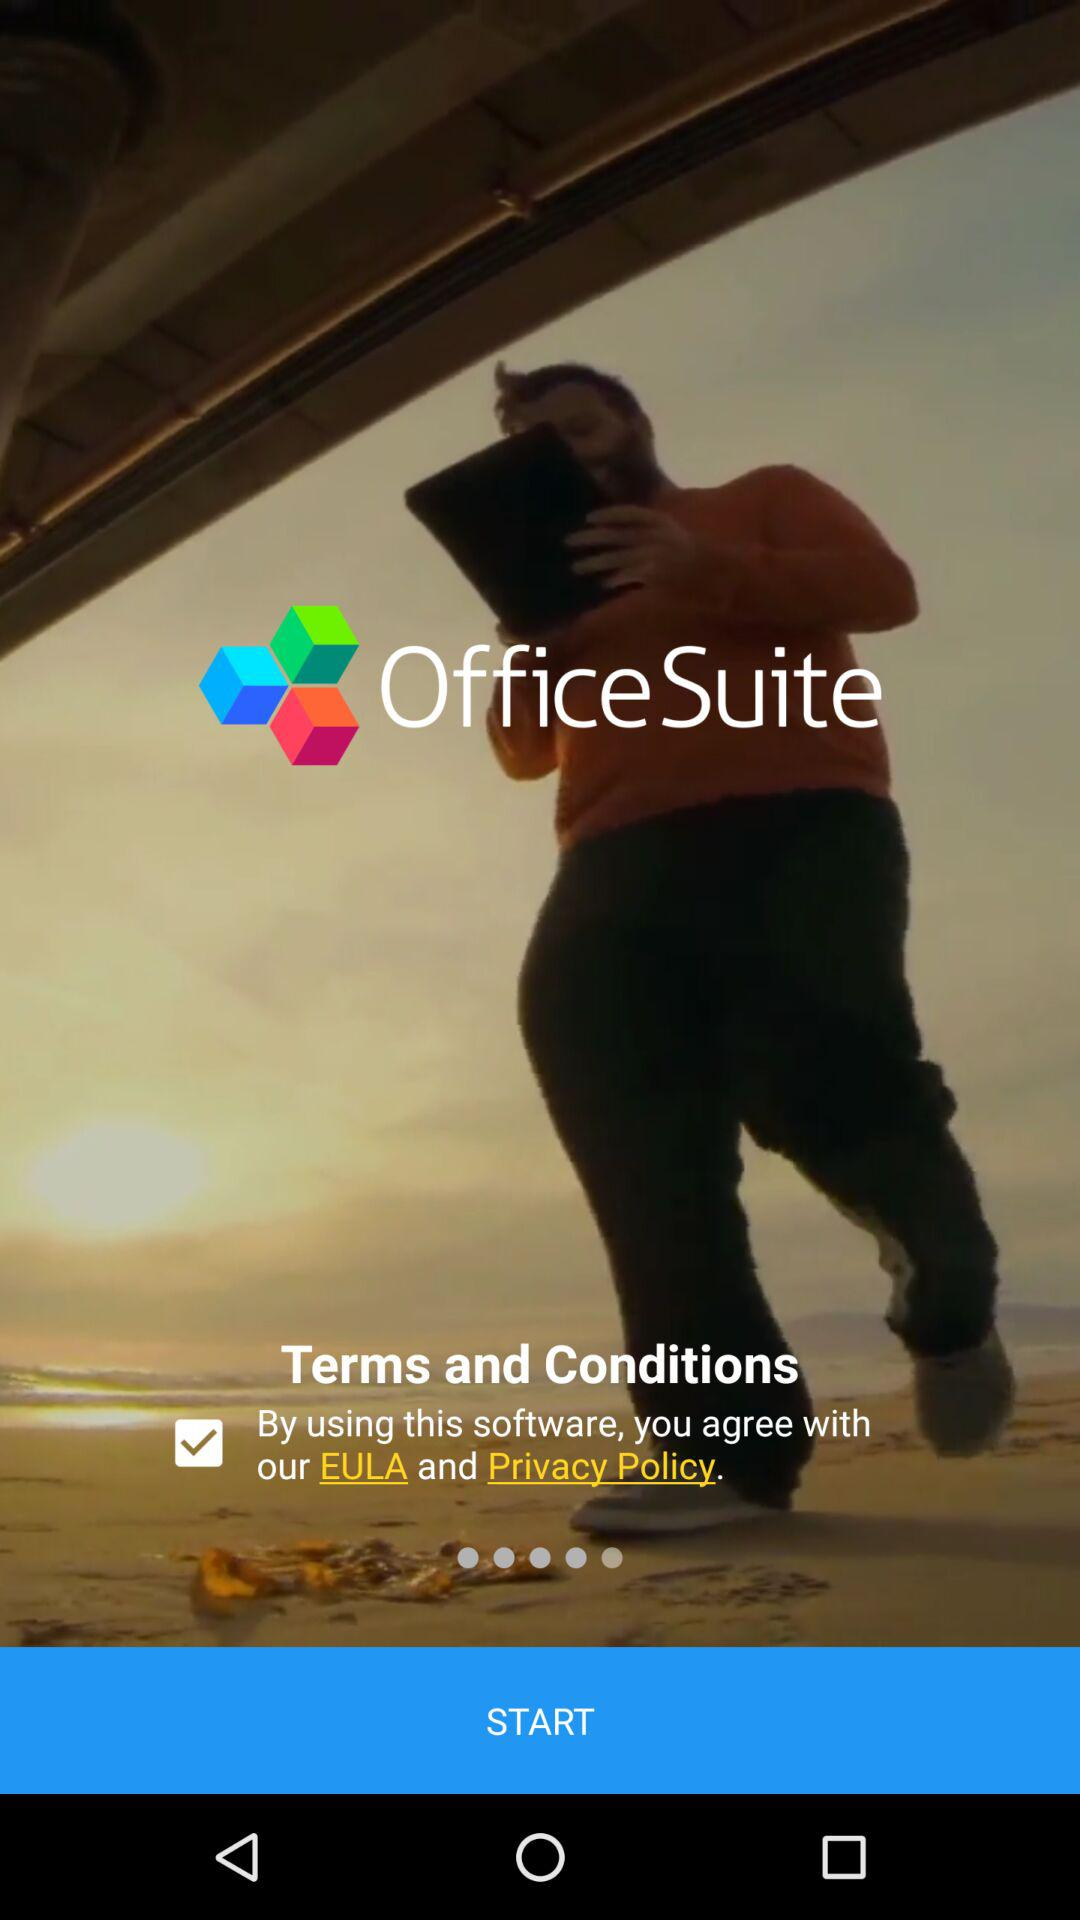What is the app title? The app title is "OfficeSuite". 